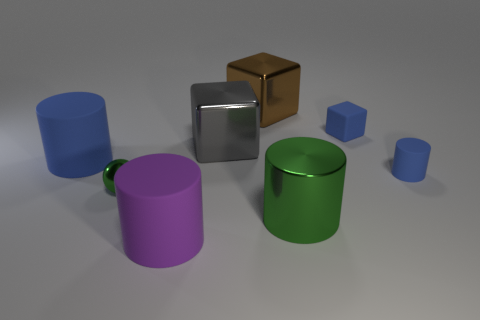What shapes can you see in the image and which colors are they? The image features various shapes: two cylinders, one large blue and one small green; two cubes, one gold and one silver; and a purple cup with a handle. Each object's color gives it a unique visual identity. 